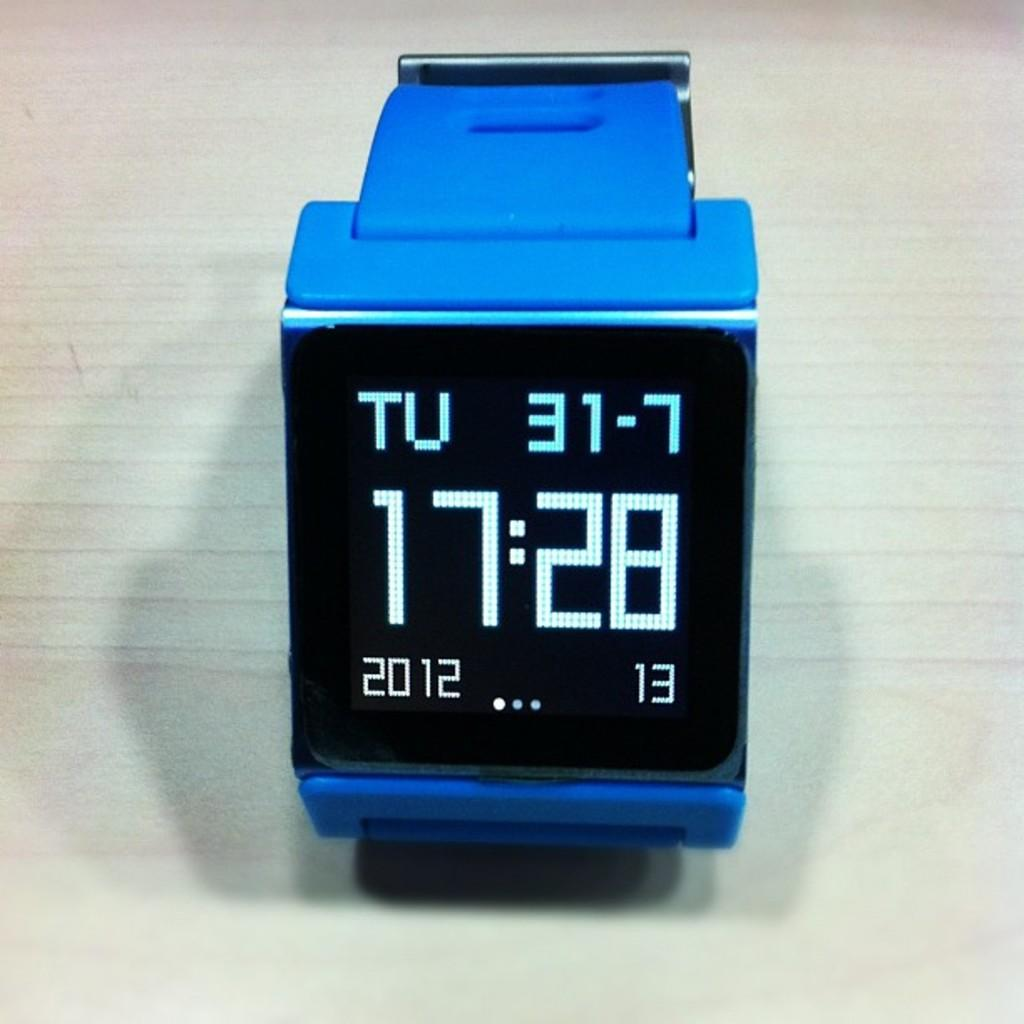<image>
Present a compact description of the photo's key features. The black LED screen of a square blue watch tells us it is 17:28 